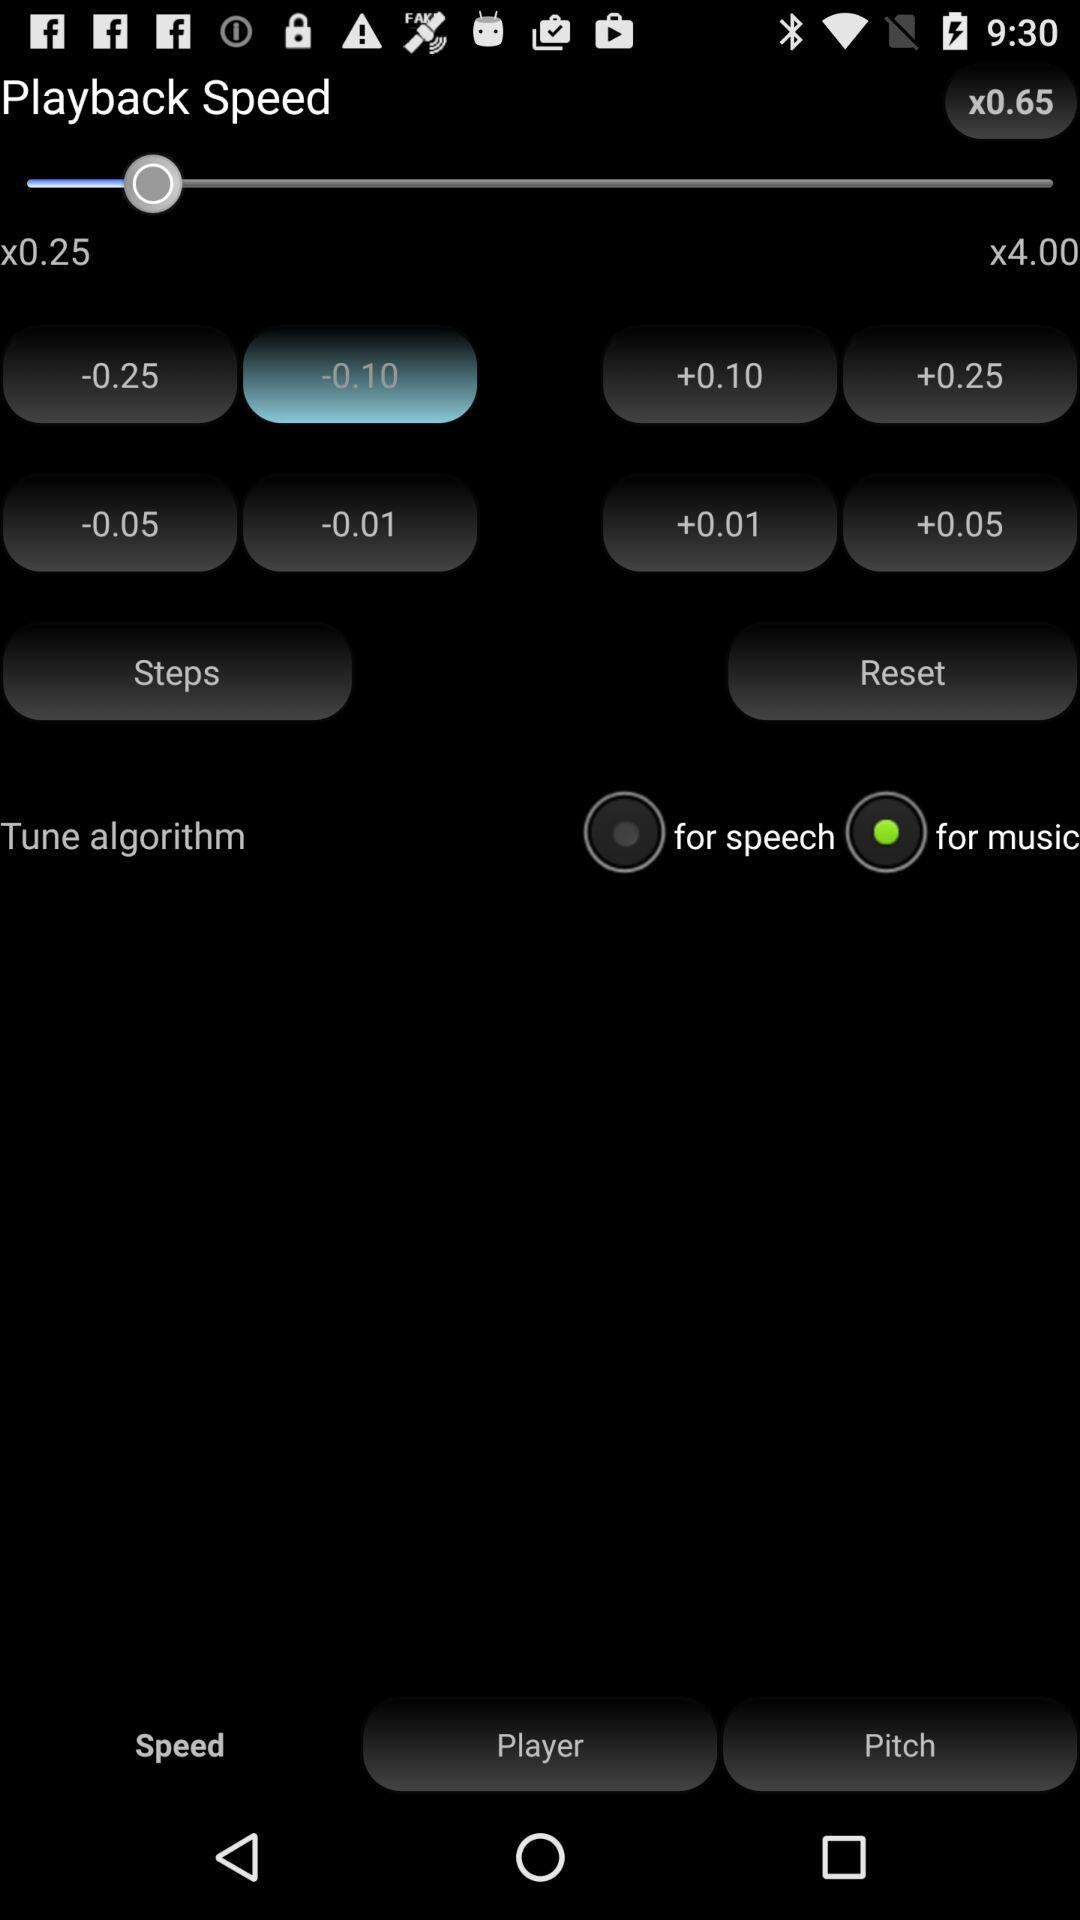Which tab is selected? The selected tab is "Speed". 